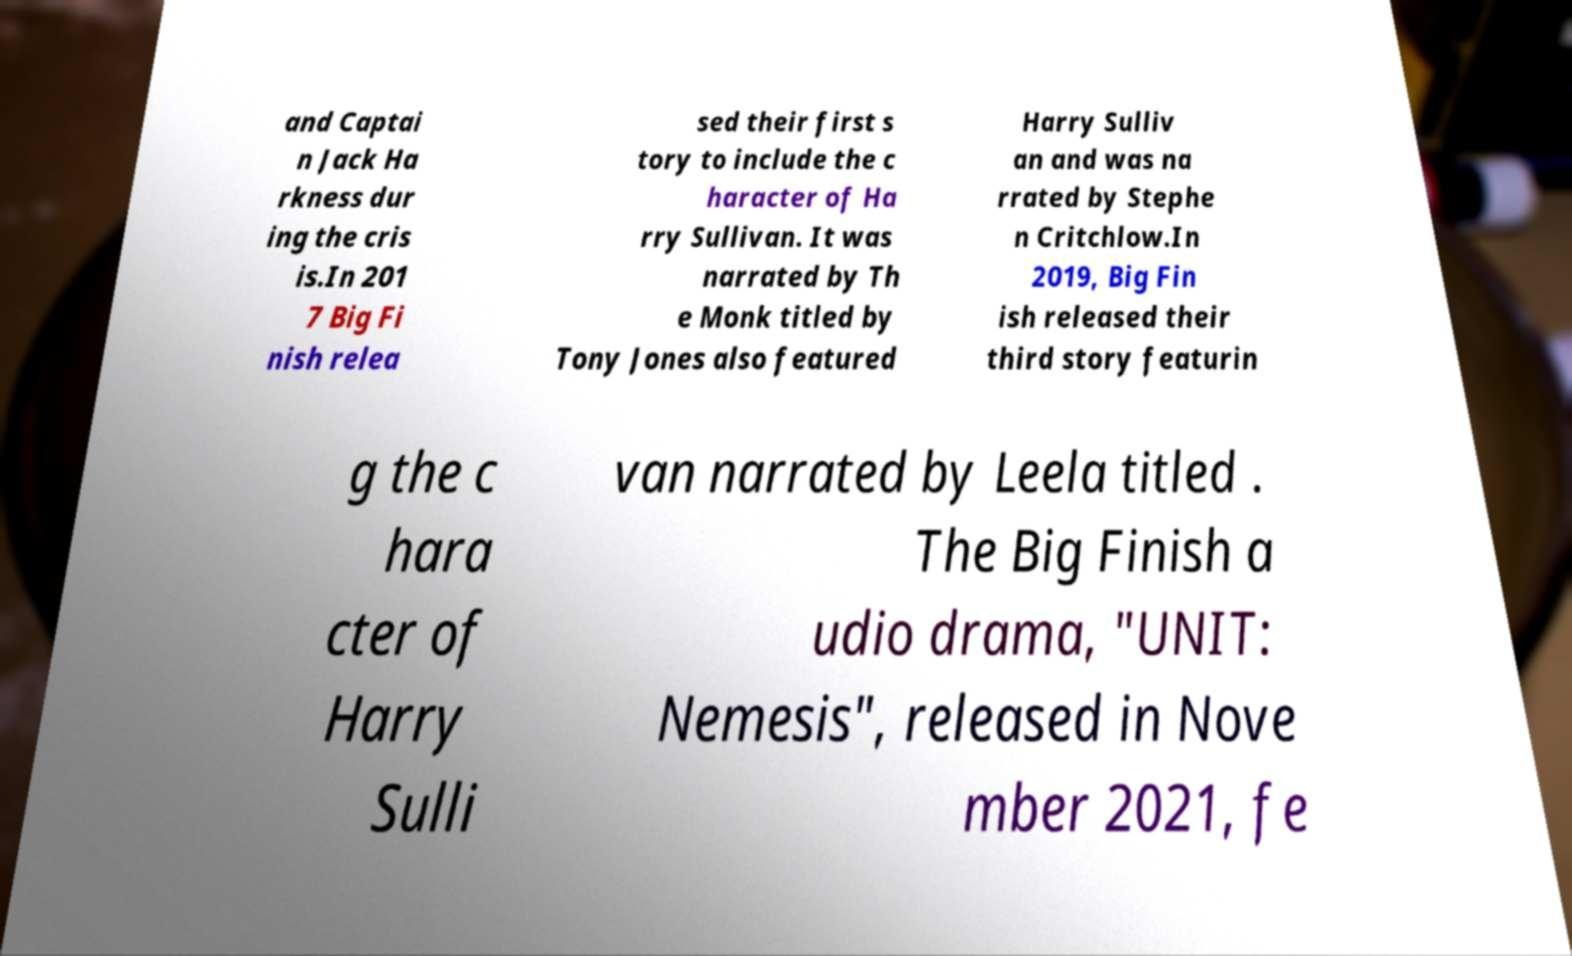Can you read and provide the text displayed in the image?This photo seems to have some interesting text. Can you extract and type it out for me? and Captai n Jack Ha rkness dur ing the cris is.In 201 7 Big Fi nish relea sed their first s tory to include the c haracter of Ha rry Sullivan. It was narrated by Th e Monk titled by Tony Jones also featured Harry Sulliv an and was na rrated by Stephe n Critchlow.In 2019, Big Fin ish released their third story featurin g the c hara cter of Harry Sulli van narrated by Leela titled . The Big Finish a udio drama, "UNIT: Nemesis", released in Nove mber 2021, fe 